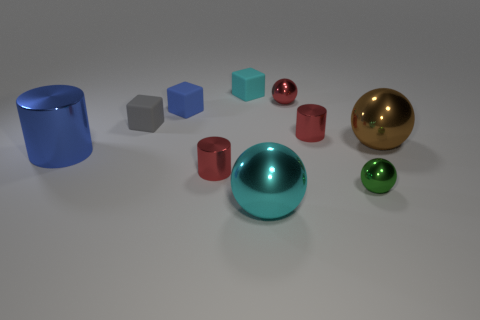Subtract all blue matte blocks. How many blocks are left? 2 Subtract all cylinders. How many objects are left? 7 Subtract 1 cubes. How many cubes are left? 2 Subtract all brown spheres. Subtract all cyan cylinders. How many spheres are left? 3 Subtract all green balls. How many purple blocks are left? 0 Subtract all tiny red blocks. Subtract all red metallic cylinders. How many objects are left? 8 Add 3 tiny cyan matte objects. How many tiny cyan matte objects are left? 4 Add 8 brown blocks. How many brown blocks exist? 8 Subtract all cyan blocks. How many blocks are left? 2 Subtract 0 cyan cylinders. How many objects are left? 10 